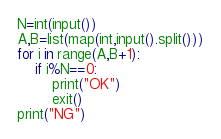Convert code to text. <code><loc_0><loc_0><loc_500><loc_500><_Python_>N=int(input())
A,B=list(map(int,input().split()))
for i in range(A,B+1):
    if i%N==0:
        print("OK")
        exit()
print("NG")</code> 